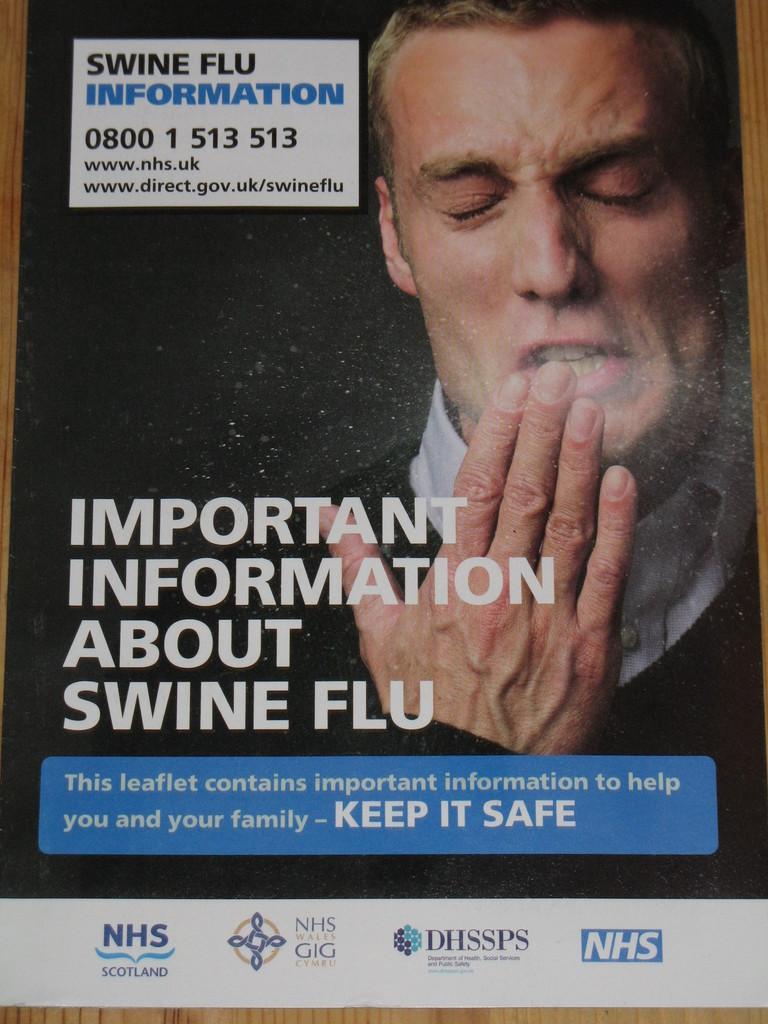In one or two sentences, can you explain what this image depicts? In this image we can see a poster. On poster we can see a person and some text printed on it. 